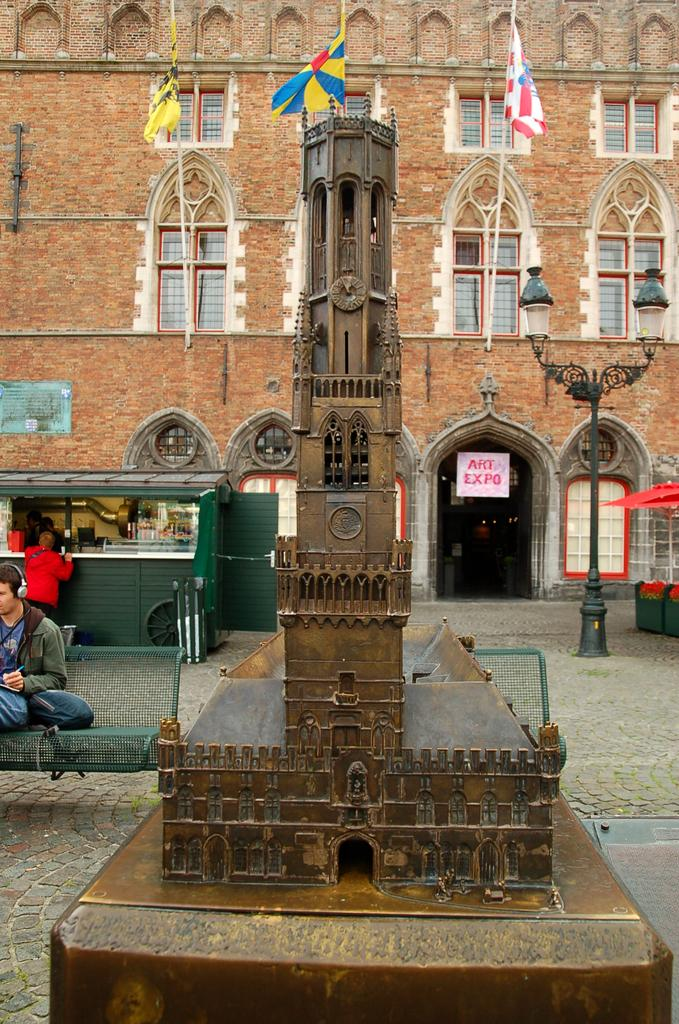What type of structure is visible in the image? There is a building in the image. What features can be seen on the building? The building has windows and doors. What type of establishment is located within the building? There is a store in the building. Are there any people present in the image? Yes, there are people in the image. What type of signage is visible in the image? There are posters with text in the image. Can you describe any other objects in the image? There is an object in the image, but its specific nature is not mentioned. Are there any flags visible in the image? Yes, there are flags in the image. What other architectural features can be seen in the image? There is a pole in the image. Are there any lighting elements in the image? Yes, there are lights in the image. What type of seating is available in the image? There are benches in the image. What type of bread is being sold at the airport in the image? There is no airport present in the image, and no mention of bread being sold. 